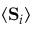Convert formula to latex. <formula><loc_0><loc_0><loc_500><loc_500>\langle S _ { i } \rangle</formula> 